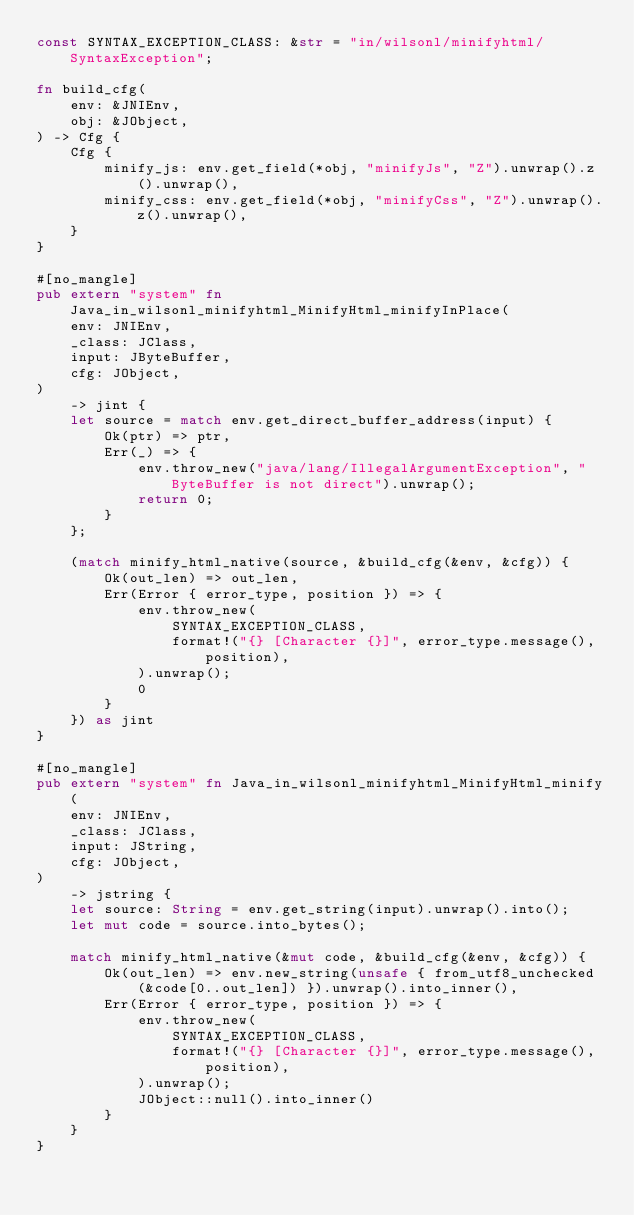Convert code to text. <code><loc_0><loc_0><loc_500><loc_500><_Rust_>const SYNTAX_EXCEPTION_CLASS: &str = "in/wilsonl/minifyhtml/SyntaxException";

fn build_cfg(
    env: &JNIEnv,
    obj: &JObject,
) -> Cfg {
    Cfg {
        minify_js: env.get_field(*obj, "minifyJs", "Z").unwrap().z().unwrap(),
        minify_css: env.get_field(*obj, "minifyCss", "Z").unwrap().z().unwrap(),
    }
}

#[no_mangle]
pub extern "system" fn Java_in_wilsonl_minifyhtml_MinifyHtml_minifyInPlace(
    env: JNIEnv,
    _class: JClass,
    input: JByteBuffer,
    cfg: JObject,
)
    -> jint {
    let source = match env.get_direct_buffer_address(input) {
        Ok(ptr) => ptr,
        Err(_) => {
            env.throw_new("java/lang/IllegalArgumentException", "ByteBuffer is not direct").unwrap();
            return 0;
        }
    };

    (match minify_html_native(source, &build_cfg(&env, &cfg)) {
        Ok(out_len) => out_len,
        Err(Error { error_type, position }) => {
            env.throw_new(
                SYNTAX_EXCEPTION_CLASS,
                format!("{} [Character {}]", error_type.message(), position),
            ).unwrap();
            0
        }
    }) as jint
}

#[no_mangle]
pub extern "system" fn Java_in_wilsonl_minifyhtml_MinifyHtml_minify(
    env: JNIEnv,
    _class: JClass,
    input: JString,
    cfg: JObject,
)
    -> jstring {
    let source: String = env.get_string(input).unwrap().into();
    let mut code = source.into_bytes();

    match minify_html_native(&mut code, &build_cfg(&env, &cfg)) {
        Ok(out_len) => env.new_string(unsafe { from_utf8_unchecked(&code[0..out_len]) }).unwrap().into_inner(),
        Err(Error { error_type, position }) => {
            env.throw_new(
                SYNTAX_EXCEPTION_CLASS,
                format!("{} [Character {}]", error_type.message(), position),
            ).unwrap();
            JObject::null().into_inner()
        }
    }
}
</code> 